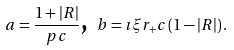Convert formula to latex. <formula><loc_0><loc_0><loc_500><loc_500>\text { } a = \frac { 1 + | R | } { p c } \text {, } b = \imath \xi r _ { + } c \left ( 1 - | R | \right ) .</formula> 